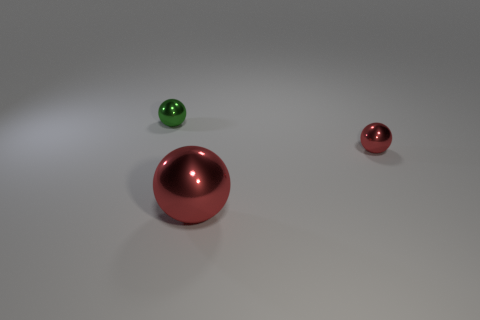There is a red shiny object on the right side of the big red object that is on the right side of the green object; what is its size?
Offer a terse response. Small. Is there a tiny metallic object of the same color as the large ball?
Offer a terse response. Yes. There is a tiny shiny object in front of the green shiny thing; is its color the same as the metallic thing that is in front of the small red sphere?
Your response must be concise. Yes. What is the shape of the big thing?
Your answer should be compact. Sphere. What number of small green metal objects are to the left of the large red metallic thing?
Ensure brevity in your answer.  1. What number of brown cubes are the same material as the small red sphere?
Ensure brevity in your answer.  0. Is there a large brown ball?
Make the answer very short. No. What is the size of the metallic object that is on the left side of the tiny red sphere and in front of the green shiny thing?
Your answer should be very brief. Large. Is the number of small metallic spheres behind the large metal ball greater than the number of small objects behind the small red sphere?
Provide a succinct answer. Yes. The other thing that is the same color as the big object is what size?
Offer a terse response. Small. 